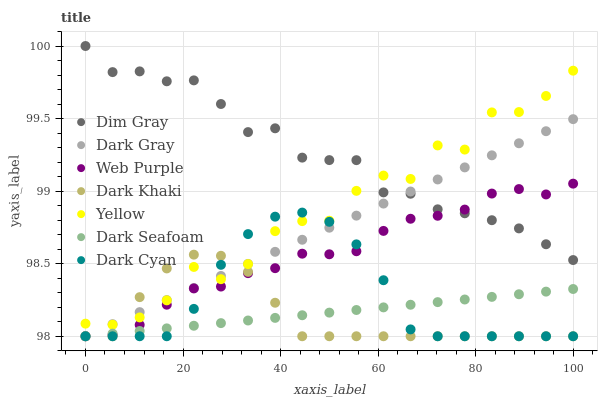Does Dark Khaki have the minimum area under the curve?
Answer yes or no. Yes. Does Dim Gray have the maximum area under the curve?
Answer yes or no. Yes. Does Dark Seafoam have the minimum area under the curve?
Answer yes or no. No. Does Dark Seafoam have the maximum area under the curve?
Answer yes or no. No. Is Dark Gray the smoothest?
Answer yes or no. Yes. Is Yellow the roughest?
Answer yes or no. Yes. Is Dim Gray the smoothest?
Answer yes or no. No. Is Dim Gray the roughest?
Answer yes or no. No. Does Dark Khaki have the lowest value?
Answer yes or no. Yes. Does Dim Gray have the lowest value?
Answer yes or no. No. Does Dim Gray have the highest value?
Answer yes or no. Yes. Does Dark Seafoam have the highest value?
Answer yes or no. No. Is Dark Seafoam less than Dim Gray?
Answer yes or no. Yes. Is Yellow greater than Dark Seafoam?
Answer yes or no. Yes. Does Dark Cyan intersect Dark Gray?
Answer yes or no. Yes. Is Dark Cyan less than Dark Gray?
Answer yes or no. No. Is Dark Cyan greater than Dark Gray?
Answer yes or no. No. Does Dark Seafoam intersect Dim Gray?
Answer yes or no. No. 